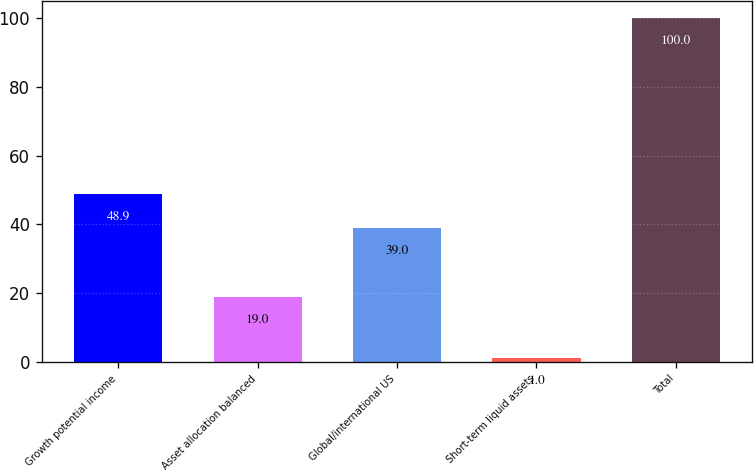Convert chart to OTSL. <chart><loc_0><loc_0><loc_500><loc_500><bar_chart><fcel>Growth potential income<fcel>Asset allocation balanced<fcel>Global/international US<fcel>Short-term liquid assets<fcel>Total<nl><fcel>48.9<fcel>19<fcel>39<fcel>1<fcel>100<nl></chart> 